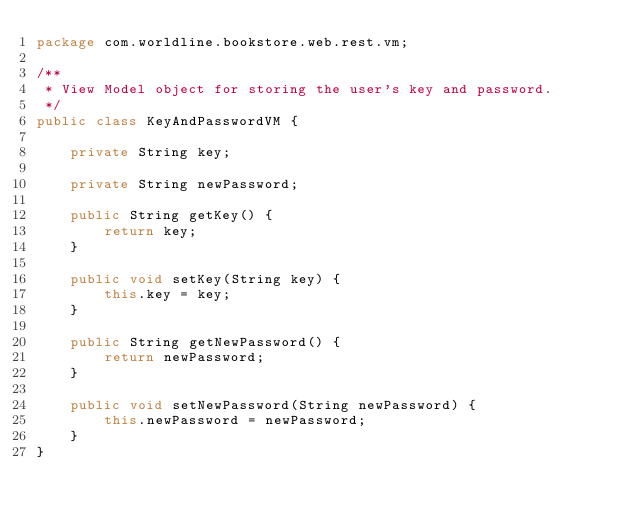Convert code to text. <code><loc_0><loc_0><loc_500><loc_500><_Java_>package com.worldline.bookstore.web.rest.vm;

/**
 * View Model object for storing the user's key and password.
 */
public class KeyAndPasswordVM {

    private String key;

    private String newPassword;

    public String getKey() {
        return key;
    }

    public void setKey(String key) {
        this.key = key;
    }

    public String getNewPassword() {
        return newPassword;
    }

    public void setNewPassword(String newPassword) {
        this.newPassword = newPassword;
    }
}
</code> 